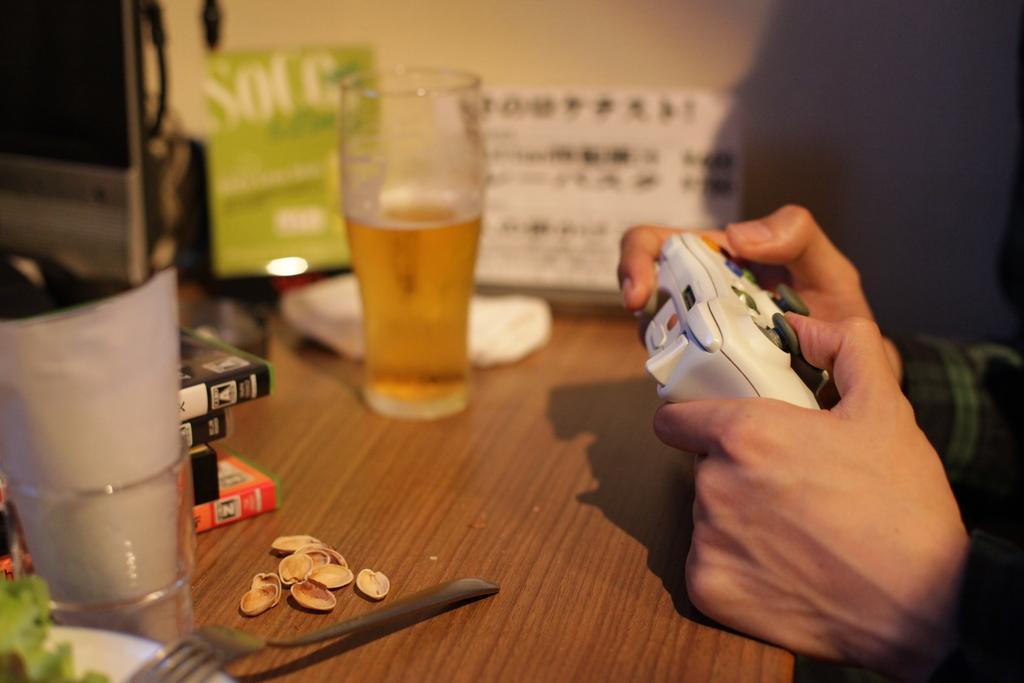How would you summarize this image in a sentence or two? In this picture, I can see a person holding joystick and i can see a glass which is half filled with wine and few books after that i can see a spoon and few dry fruits. 